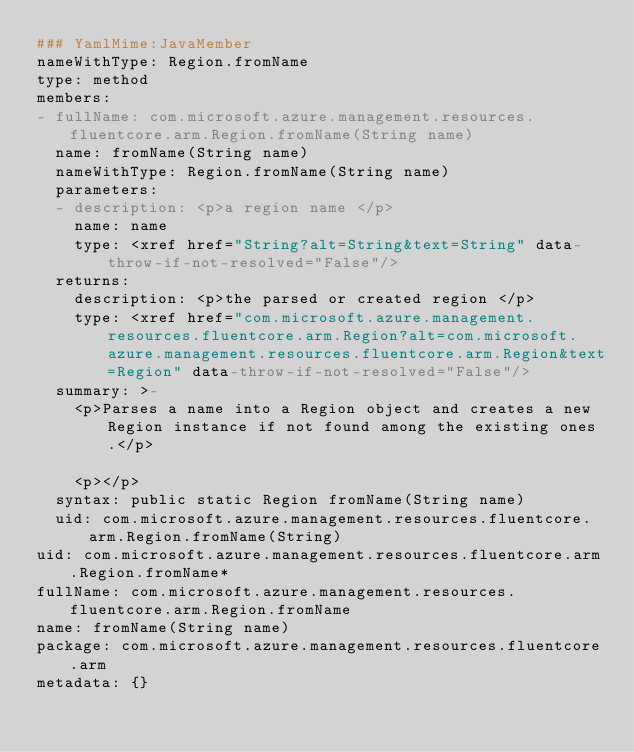<code> <loc_0><loc_0><loc_500><loc_500><_YAML_>### YamlMime:JavaMember
nameWithType: Region.fromName
type: method
members:
- fullName: com.microsoft.azure.management.resources.fluentcore.arm.Region.fromName(String name)
  name: fromName(String name)
  nameWithType: Region.fromName(String name)
  parameters:
  - description: <p>a region name </p>
    name: name
    type: <xref href="String?alt=String&text=String" data-throw-if-not-resolved="False"/>
  returns:
    description: <p>the parsed or created region </p>
    type: <xref href="com.microsoft.azure.management.resources.fluentcore.arm.Region?alt=com.microsoft.azure.management.resources.fluentcore.arm.Region&text=Region" data-throw-if-not-resolved="False"/>
  summary: >-
    <p>Parses a name into a Region object and creates a new Region instance if not found among the existing ones.</p>

    <p></p>
  syntax: public static Region fromName(String name)
  uid: com.microsoft.azure.management.resources.fluentcore.arm.Region.fromName(String)
uid: com.microsoft.azure.management.resources.fluentcore.arm.Region.fromName*
fullName: com.microsoft.azure.management.resources.fluentcore.arm.Region.fromName
name: fromName(String name)
package: com.microsoft.azure.management.resources.fluentcore.arm
metadata: {}
</code> 